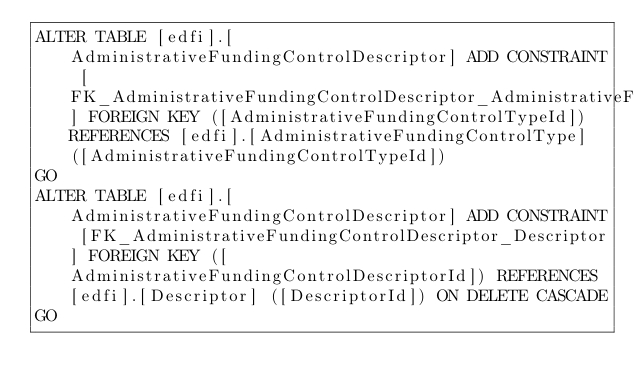Convert code to text. <code><loc_0><loc_0><loc_500><loc_500><_SQL_>ALTER TABLE [edfi].[AdministrativeFundingControlDescriptor] ADD CONSTRAINT [FK_AdministrativeFundingControlDescriptor_AdministrativeFundingControlType] FOREIGN KEY ([AdministrativeFundingControlTypeId]) REFERENCES [edfi].[AdministrativeFundingControlType] ([AdministrativeFundingControlTypeId])
GO
ALTER TABLE [edfi].[AdministrativeFundingControlDescriptor] ADD CONSTRAINT [FK_AdministrativeFundingControlDescriptor_Descriptor] FOREIGN KEY ([AdministrativeFundingControlDescriptorId]) REFERENCES [edfi].[Descriptor] ([DescriptorId]) ON DELETE CASCADE
GO
</code> 